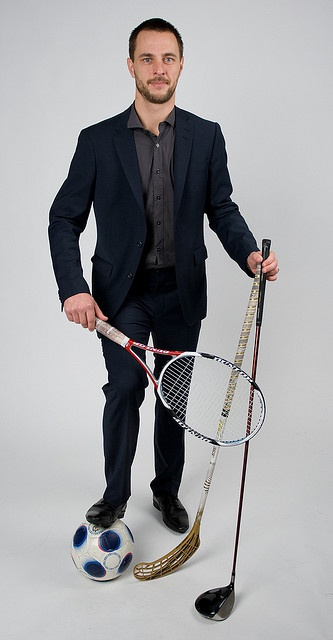Describe the objects in this image and their specific colors. I can see people in darkgray, black, salmon, lightgray, and gray tones, tennis racket in darkgray, lightgray, black, and gray tones, and sports ball in darkgray, lightgray, black, and navy tones in this image. 